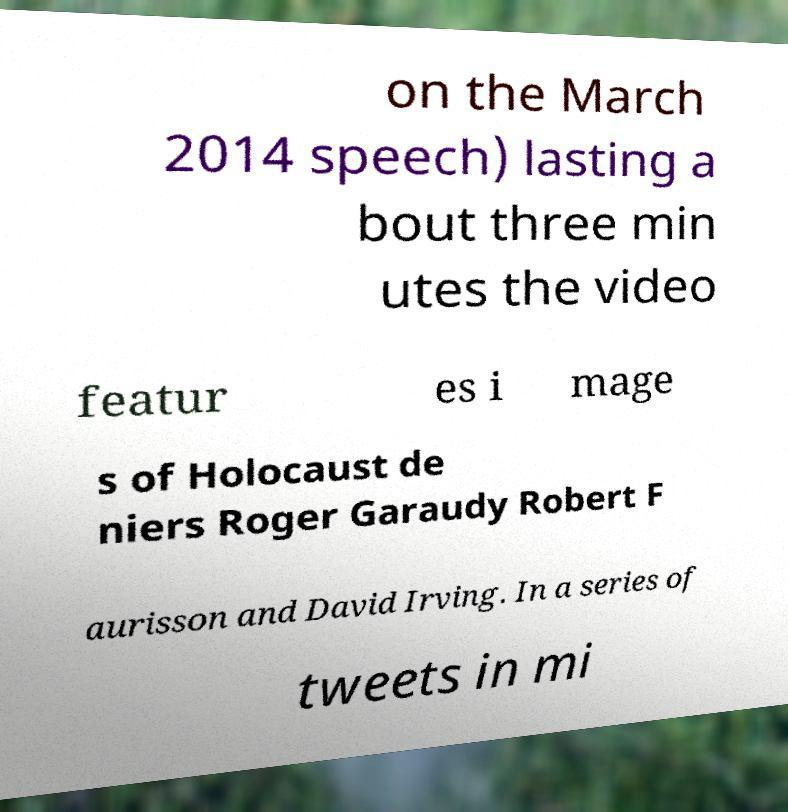For documentation purposes, I need the text within this image transcribed. Could you provide that? on the March 2014 speech) lasting a bout three min utes the video featur es i mage s of Holocaust de niers Roger Garaudy Robert F aurisson and David Irving. In a series of tweets in mi 